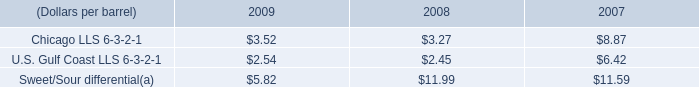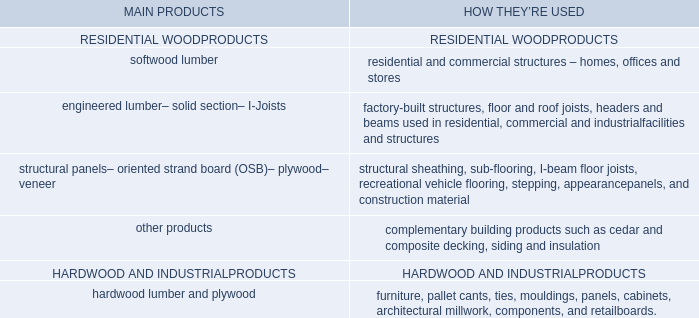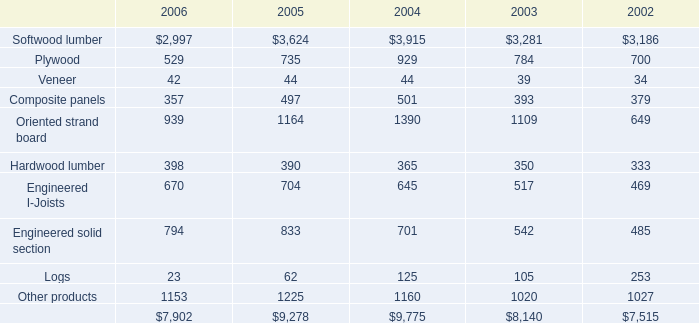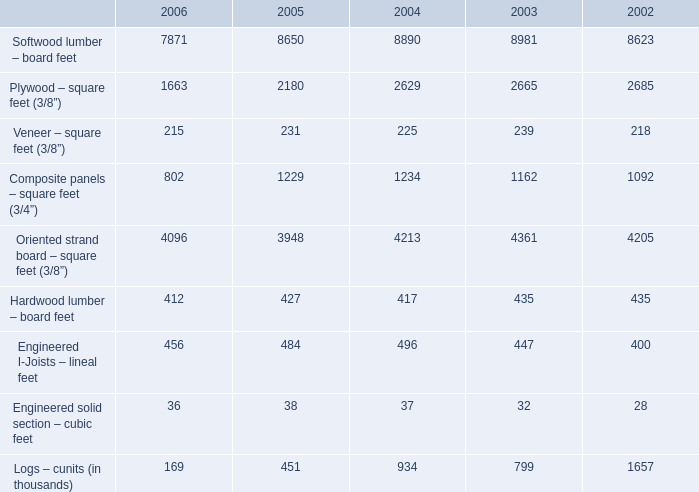What's the total amount of the Softwood lumber – board feet in the years whereSoftwood lumber – board feet is greater than 8700? 
Computations: (8890 + 8981)
Answer: 17871.0. 